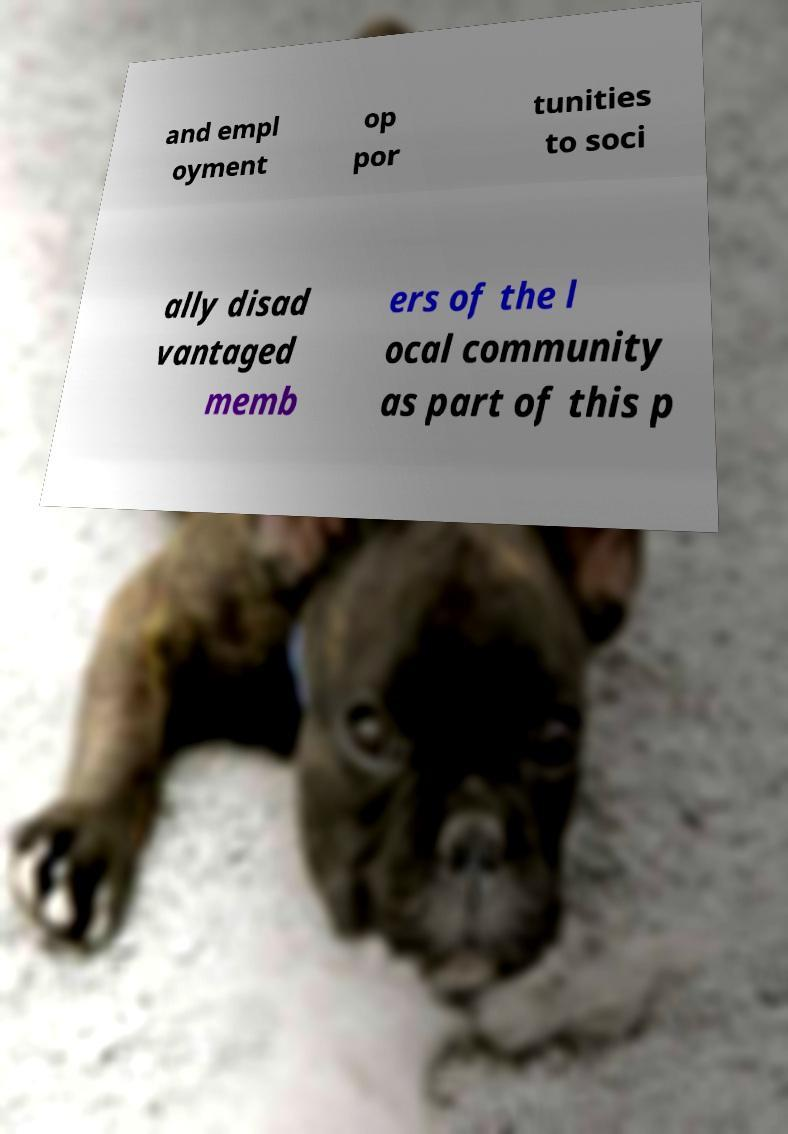Can you read and provide the text displayed in the image?This photo seems to have some interesting text. Can you extract and type it out for me? and empl oyment op por tunities to soci ally disad vantaged memb ers of the l ocal community as part of this p 